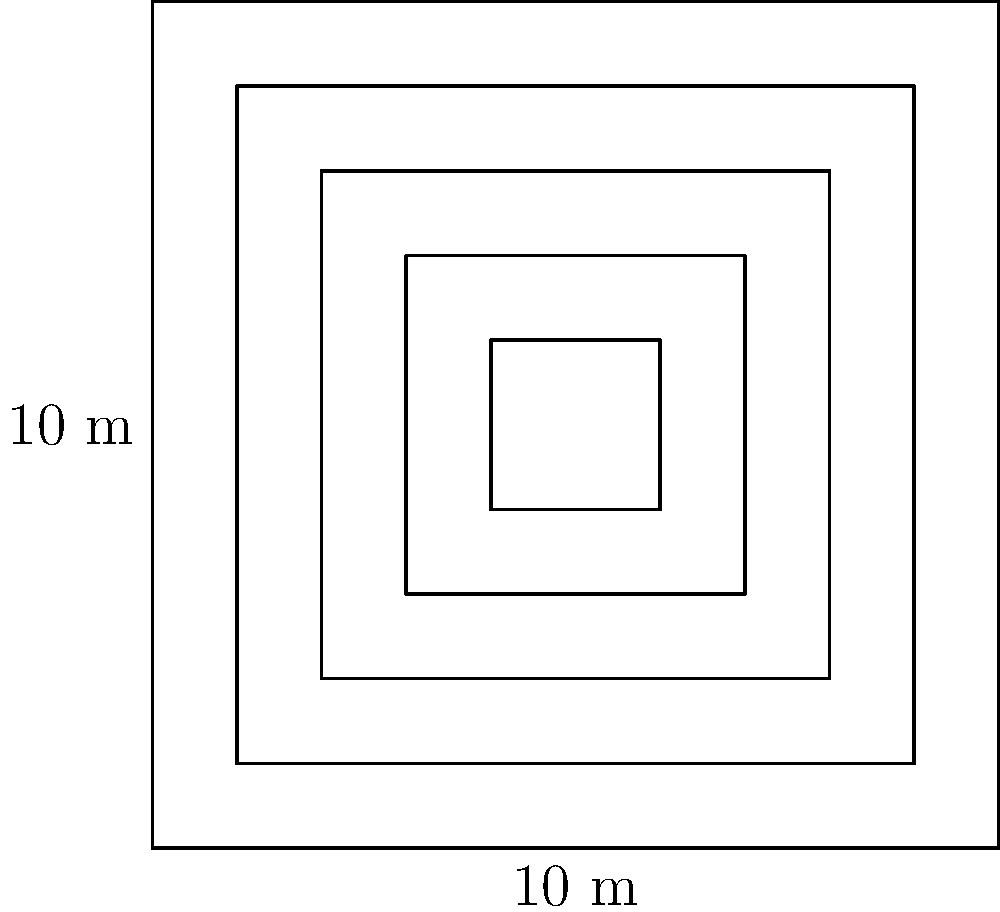As part of preserving our colonial heritage, we are restoring a traditional British garden maze. The maze consists of concentric square hedges, as shown in the diagram. If the outermost square has sides of 10 meters, and each subsequent inner square is 1 meter smaller on each side, what is the total perimeter of all the hedges in the maze? Let's approach this step-by-step:

1) We have 5 squares in total.

2) The perimeters of each square are:
   - Outermost square: $4 \times 10 = 40$ meters
   - Second square: $4 \times 8 = 32$ meters
   - Third square: $4 \times 6 = 24$ meters
   - Fourth square: $4 \times 4 = 16$ meters
   - Innermost square: $4 \times 2 = 8$ meters

3) To calculate the total perimeter, we sum these up:

   $$ 40 + 32 + 24 + 16 + 8 = 120 $$

Therefore, the total perimeter of all hedges in the maze is 120 meters.
Answer: 120 meters 